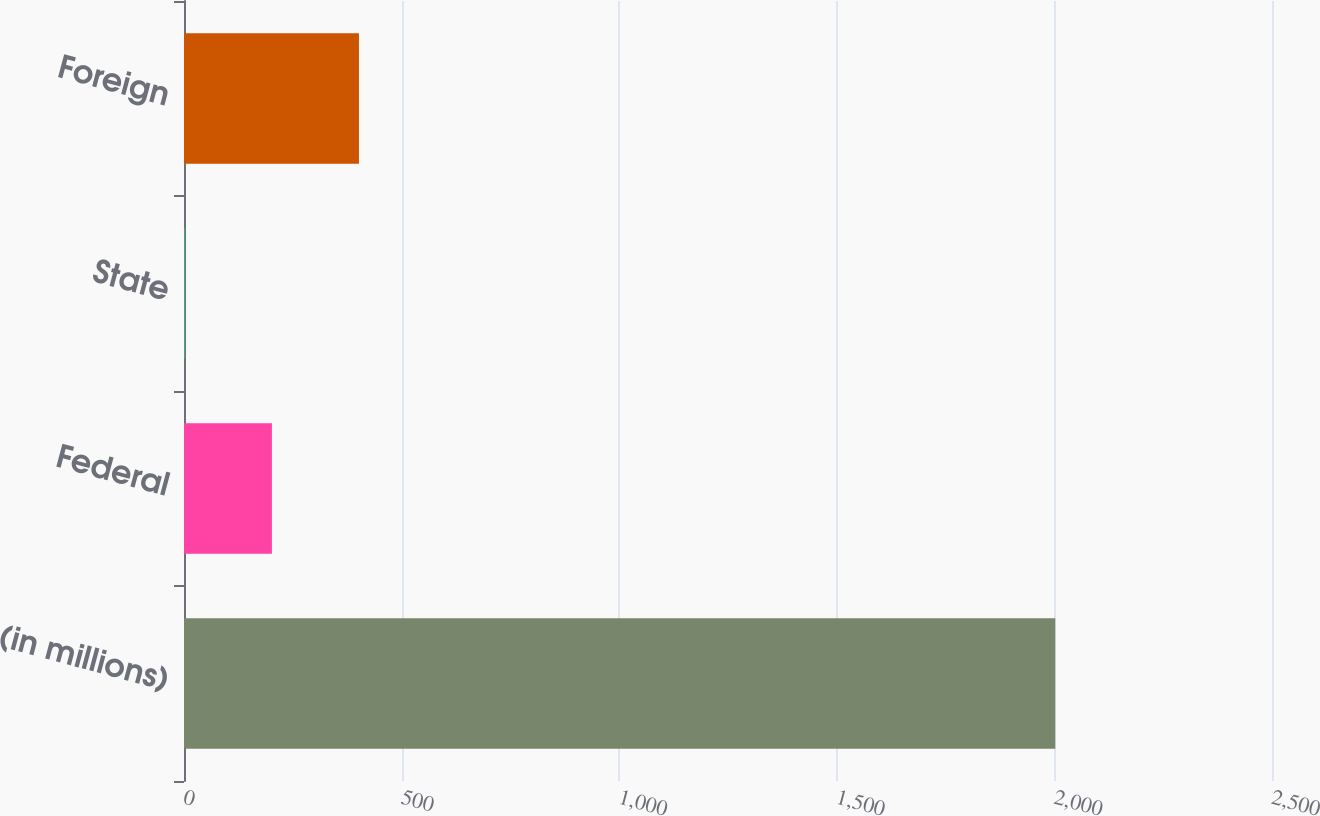<chart> <loc_0><loc_0><loc_500><loc_500><bar_chart><fcel>(in millions)<fcel>Federal<fcel>State<fcel>Foreign<nl><fcel>2002<fcel>202<fcel>2<fcel>402<nl></chart> 